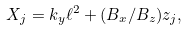Convert formula to latex. <formula><loc_0><loc_0><loc_500><loc_500>X _ { j } = k _ { y } \ell ^ { 2 } + ( { B _ { x } } / B _ { z } ) z _ { j } ,</formula> 